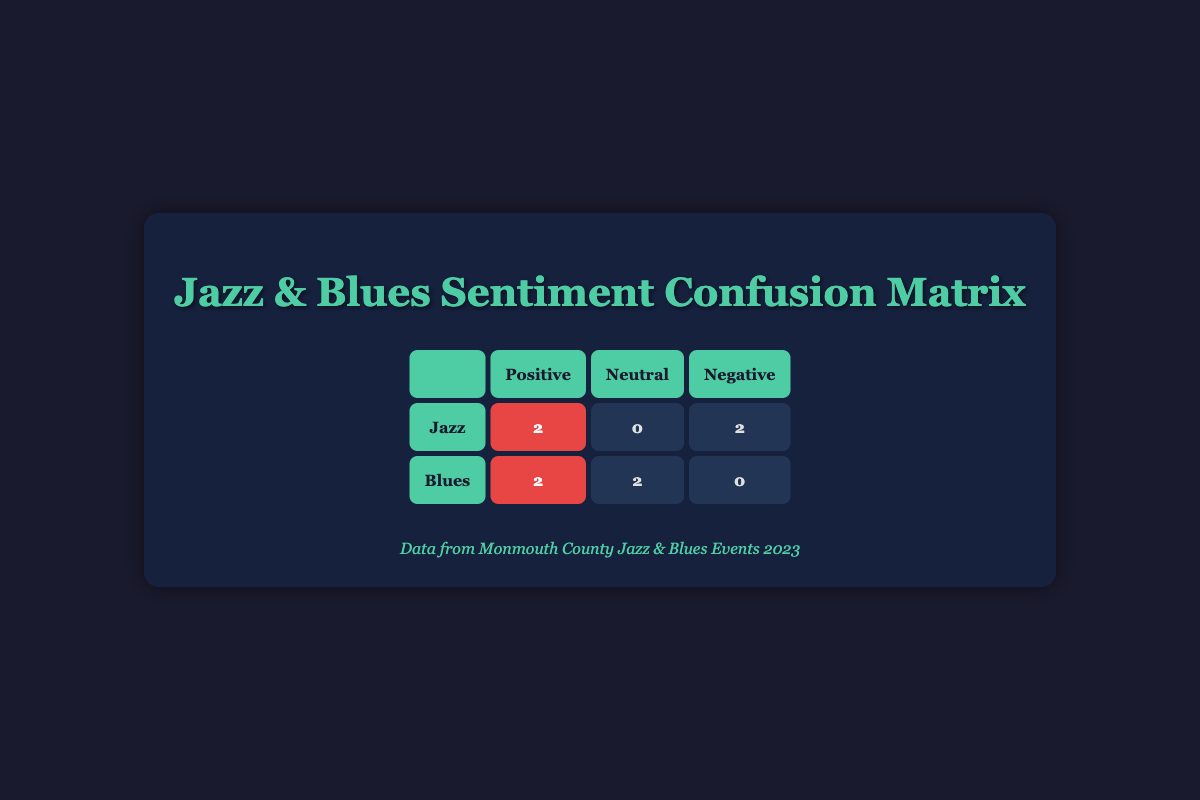What is the total number of positive sentiments for jazz events? From the table, the positive sentiments for jazz events are 2 (from Blue Mood Live at The Stone Pony and Jazz Night at The Count Basie Center). Therefore, the total is 2.
Answer: 2 What is the number of neutral sentiments for blues events? Referring to the table, the number of neutral sentiments for blues events is 2 (from Blues Jam Session at Downtown Asbury Park and Blues Fest at Pier Village).
Answer: 2 Is there any jazz event with a positive sentiment? Looking at the table, there are two jazz events marked with positive sentiment: Blue Mood Live at The Stone Pony and Jazz Night at The Count Basie Center. Thus, the answer is yes.
Answer: Yes How many total events had a negative sentiment? The table lists two events with negative sentiments: Jazz Under the Stars at Monmouth Park and Jazz Appreciation Month Gala. Adding these gives a total of 2 events.
Answer: 2 What is the difference between the number of positive sentiments for jazz and blues events? Jazz events have 2 positive sentiments, while blues events also have 2 positive sentiments. Therefore, the difference is 2 - 2 = 0.
Answer: 0 Which sentiment category had the most events? Positive sentiments include 4 events (2 jazz and 2 blues). Neutral sentiments have 2 events (1 jazz and 1 blues), and negative sentiments have also 2 events (2 jazz). Therefore, the category with the most events is positive sentiment.
Answer: Positive How many total events featured jazz compared to blues? The table shows that there are 4 jazz events (2 positive, 2 negative) and 4 blues events (2 positive, 2 neutral). Both genres have the same number of events, leading to a total of 4 each.
Answer: 4 jazz and 4 blues What percentage of blues events had a positive sentiment? In the blues events, there are 2 out of 4 events with a positive sentiment. To find the percentage, we calculate (2/4) * 100 = 50%.
Answer: 50% 